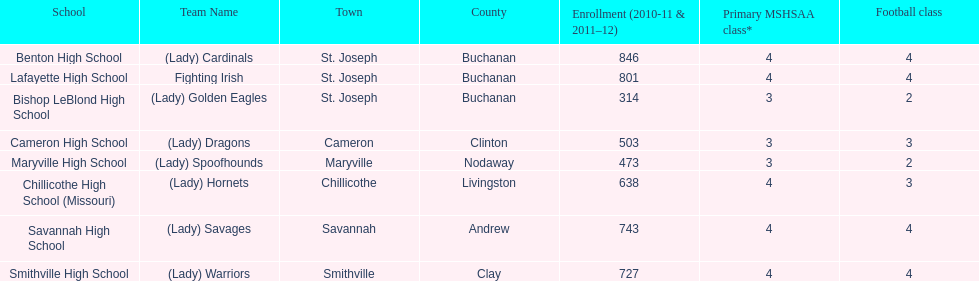In which school is the largest population of enrolled students? Benton High School. 